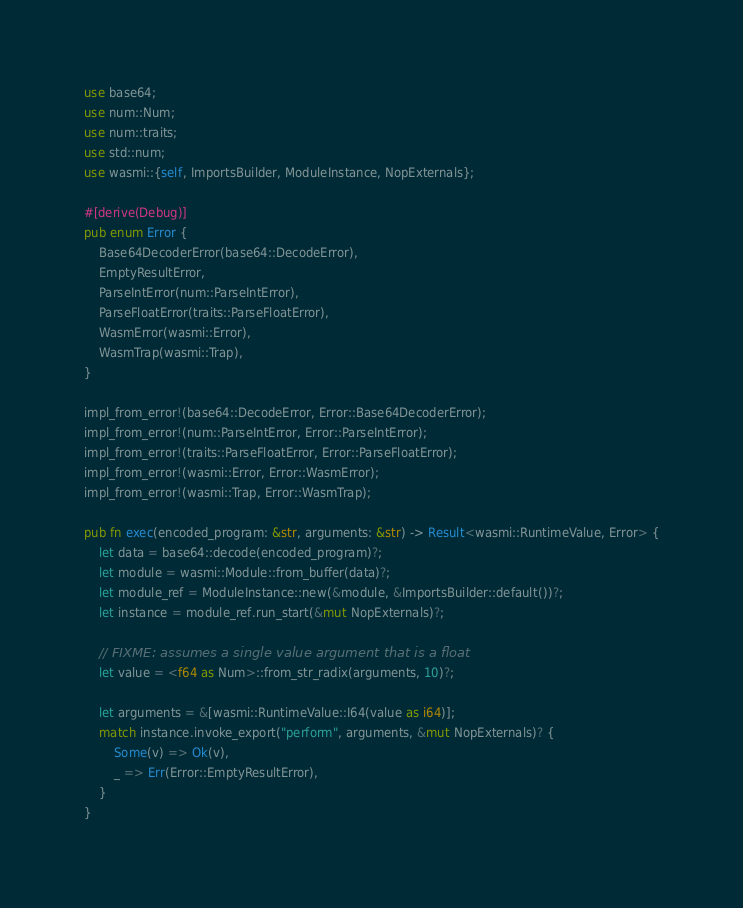<code> <loc_0><loc_0><loc_500><loc_500><_Rust_>use base64;
use num::Num;
use num::traits;
use std::num;
use wasmi::{self, ImportsBuilder, ModuleInstance, NopExternals};

#[derive(Debug)]
pub enum Error {
    Base64DecoderError(base64::DecodeError),
    EmptyResultError,
    ParseIntError(num::ParseIntError),
    ParseFloatError(traits::ParseFloatError),
    WasmError(wasmi::Error),
    WasmTrap(wasmi::Trap),
}

impl_from_error!(base64::DecodeError, Error::Base64DecoderError);
impl_from_error!(num::ParseIntError, Error::ParseIntError);
impl_from_error!(traits::ParseFloatError, Error::ParseFloatError);
impl_from_error!(wasmi::Error, Error::WasmError);
impl_from_error!(wasmi::Trap, Error::WasmTrap);

pub fn exec(encoded_program: &str, arguments: &str) -> Result<wasmi::RuntimeValue, Error> {
    let data = base64::decode(encoded_program)?;
    let module = wasmi::Module::from_buffer(data)?;
    let module_ref = ModuleInstance::new(&module, &ImportsBuilder::default())?;
    let instance = module_ref.run_start(&mut NopExternals)?;

    // FIXME: assumes a single value argument that is a float
    let value = <f64 as Num>::from_str_radix(arguments, 10)?;

    let arguments = &[wasmi::RuntimeValue::I64(value as i64)];
    match instance.invoke_export("perform", arguments, &mut NopExternals)? {
        Some(v) => Ok(v),
        _ => Err(Error::EmptyResultError),
    }
}
</code> 